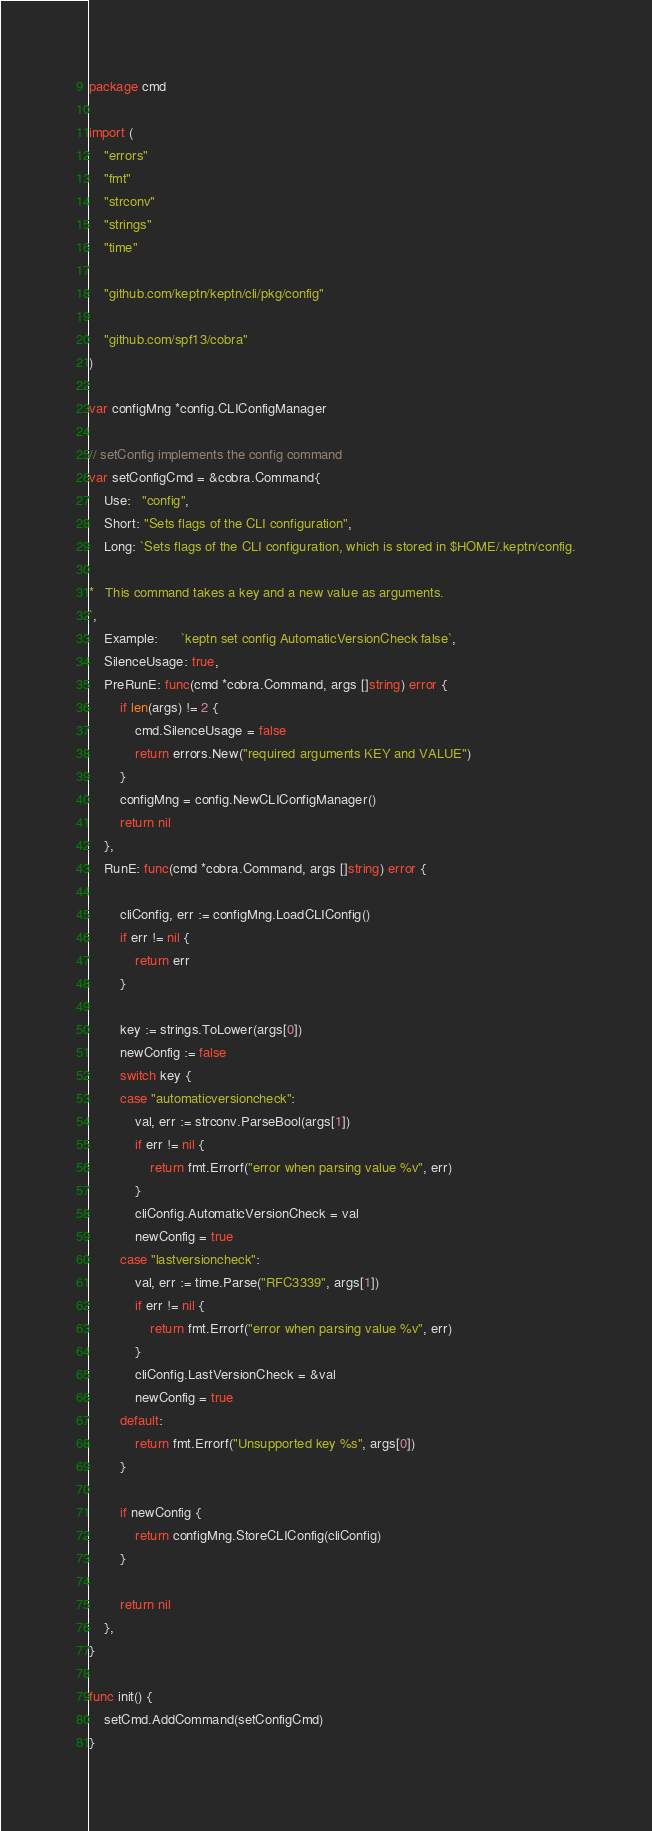<code> <loc_0><loc_0><loc_500><loc_500><_Go_>package cmd

import (
	"errors"
	"fmt"
	"strconv"
	"strings"
	"time"

	"github.com/keptn/keptn/cli/pkg/config"

	"github.com/spf13/cobra"
)

var configMng *config.CLIConfigManager

// setConfig implements the config command
var setConfigCmd = &cobra.Command{
	Use:   "config",
	Short: "Sets flags of the CLI configuration",
	Long: `Sets flags of the CLI configuration, which is stored in $HOME/.keptn/config.

*	This command takes a key and a new value as arguments. 
`,
	Example:      `keptn set config AutomaticVersionCheck false`,
	SilenceUsage: true,
	PreRunE: func(cmd *cobra.Command, args []string) error {
		if len(args) != 2 {
			cmd.SilenceUsage = false
			return errors.New("required arguments KEY and VALUE")
		}
		configMng = config.NewCLIConfigManager()
		return nil
	},
	RunE: func(cmd *cobra.Command, args []string) error {

		cliConfig, err := configMng.LoadCLIConfig()
		if err != nil {
			return err
		}

		key := strings.ToLower(args[0])
		newConfig := false
		switch key {
		case "automaticversioncheck":
			val, err := strconv.ParseBool(args[1])
			if err != nil {
				return fmt.Errorf("error when parsing value %v", err)
			}
			cliConfig.AutomaticVersionCheck = val
			newConfig = true
		case "lastversioncheck":
			val, err := time.Parse("RFC3339", args[1])
			if err != nil {
				return fmt.Errorf("error when parsing value %v", err)
			}
			cliConfig.LastVersionCheck = &val
			newConfig = true
		default:
			return fmt.Errorf("Unsupported key %s", args[0])
		}

		if newConfig {
			return configMng.StoreCLIConfig(cliConfig)
		}

		return nil
	},
}

func init() {
	setCmd.AddCommand(setConfigCmd)
}
</code> 